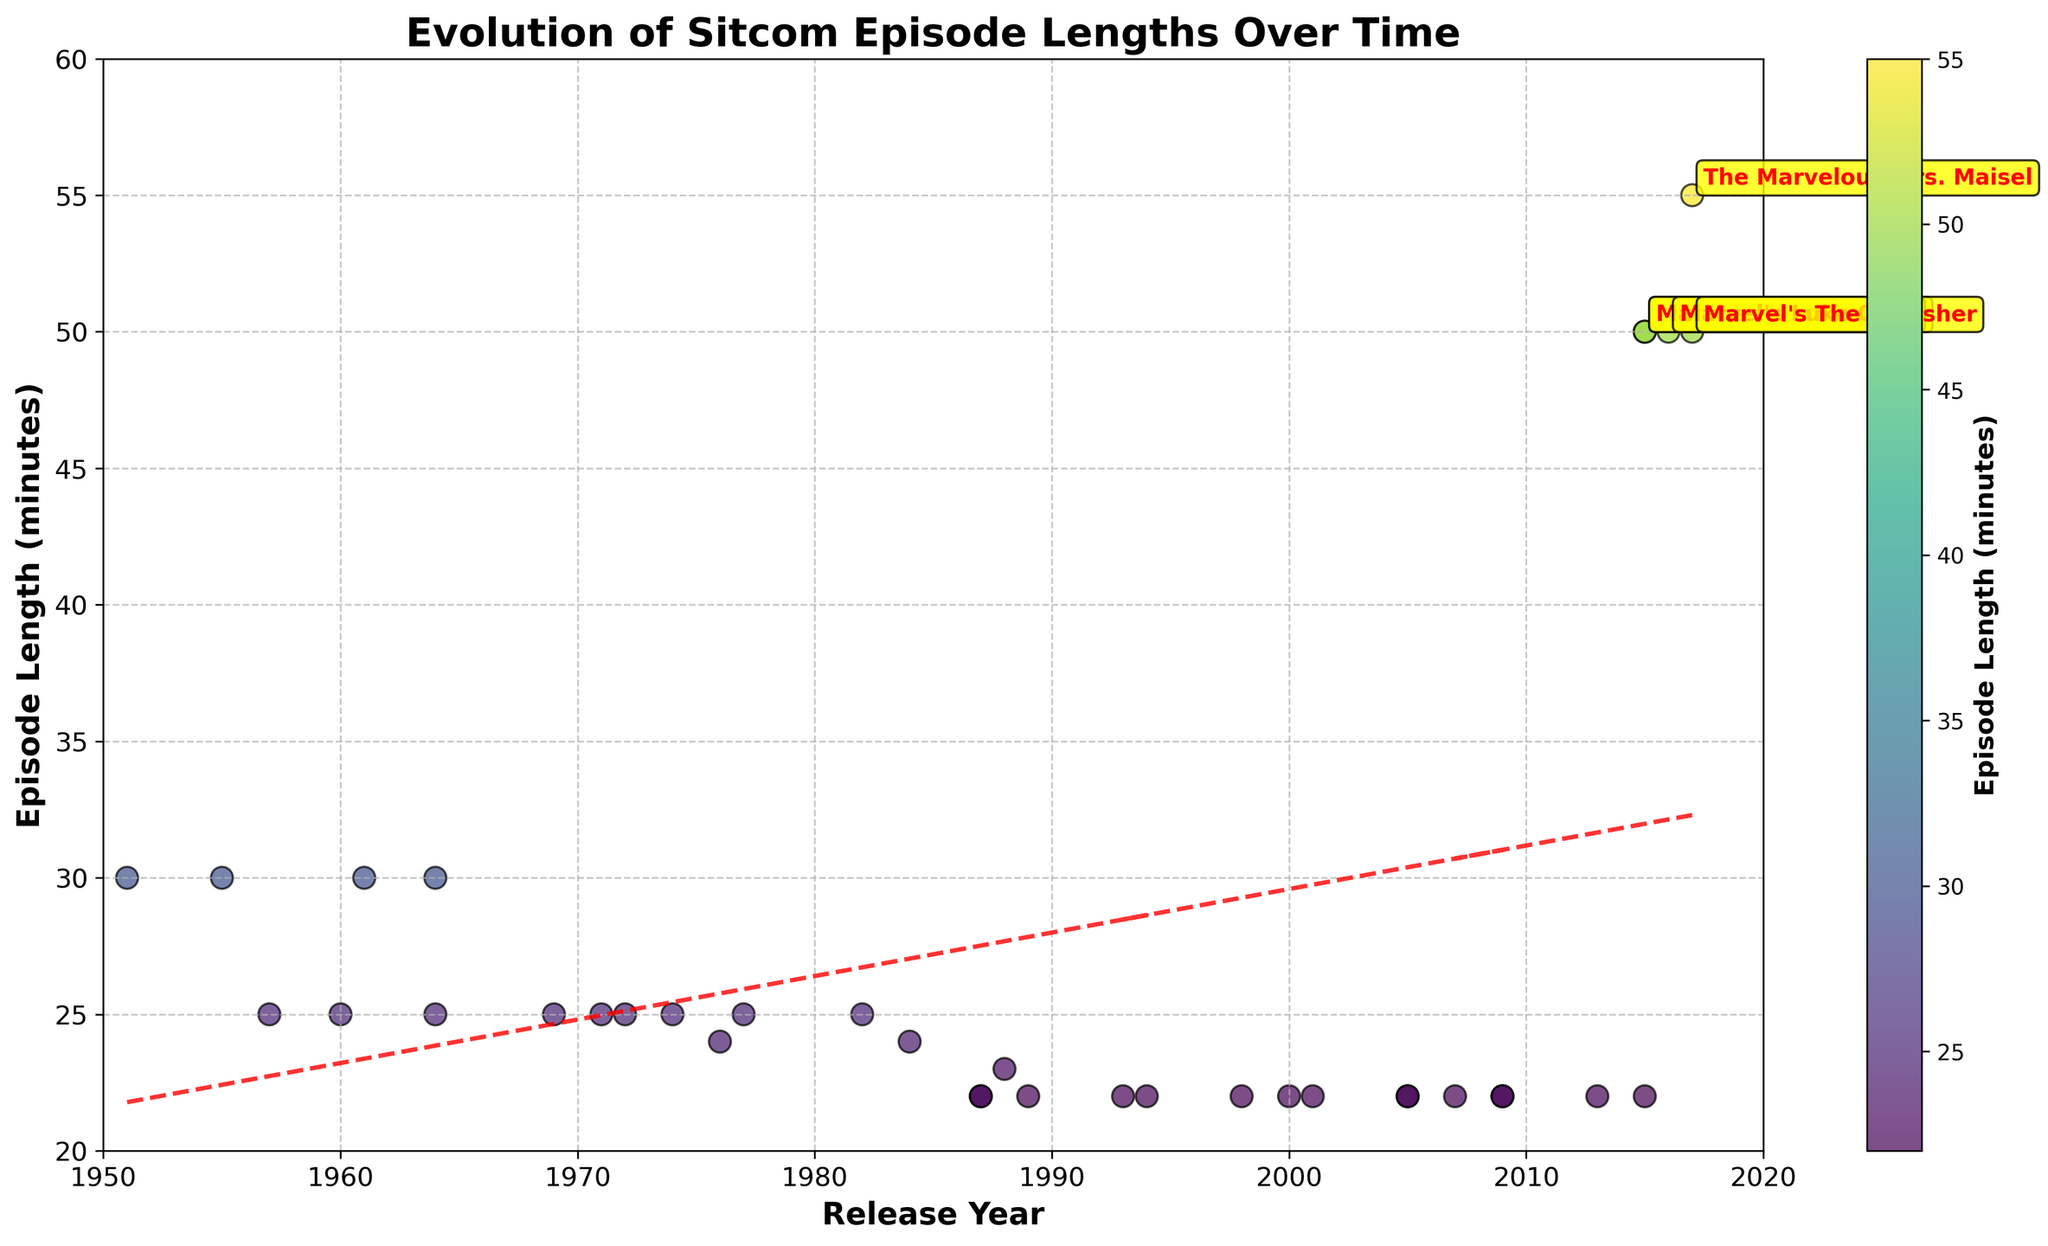What is the title of the plot? The title is usually located at the top of the plot. This plot has "Evolution of Sitcom Episode Lengths Over Time" as its title.
Answer: Evolution of Sitcom Episode Lengths Over Time What are the axes labels of the plot? Axes labels describe what each axis represents. In this plot, the x-axis is labeled "Release Year," and the y-axis is labeled "Episode Length (minutes)."
Answer: Release Year, Episode Length (minutes) What is the average length of sitcom episodes released in the 1960s? Identify the data points from the 1960s and calculate their average. Shows from the 1960s and their lengths are "The Andy Griffith Show" (25 mins), "The Dick Van Dyke Show" (30 mins), "Bewitched" (30 mins), "Gilligan's Island" (25 mins), and "The Brady Bunch" (25 mins). The average is (25 + 30 + 30 + 25 + 25) / 5 = 27
Answer: 27 How many Marvel shows are annotated on the plot? Look for red text with yellow bounding boxes which denote Marvel shows. The shows are "Marvel's Daredevil," "Marvel's Jessica Jones," "Marvel's Luke Cage," and "Marvel's The Punisher," making a total of four.
Answer: 4 Which show has the longest episode length in the dataset? The longest episode length is found by looking for the highest point on the y-axis. "The Marvelous Mrs. Maisel" at 55 minutes is the longest.
Answer: The Marvelous Mrs. Maisel Did episode lengths generally increase or decrease over time, according to the trend line? Observe the direction of the trend line from left to right. The trend line slopes downward, indicating that episode lengths generally decreased over time.
Answer: Decrease Compare episode lengths between "I Love Lucy" and "The Office." Which one is longer? Find the data points for these two shows: "I Love Lucy" has an episode length of 30 minutes, while "The Office" has 22 minutes. Thus, "I Love Lucy" is longer.
Answer: I Love Lucy How many shows from the dataset have an episode length of exactly 22 minutes? Identify the shows on the scatter plot at the 22-minute level. They are: "Married... with Children," "Full House," "Seinfeld," "Friends," "Frasier," "That '70s Show," "Malcolm in the Middle," "Scrubs," "The Office," "How I Met Your Mother," "Parks and Recreation," "Modern Family," "The Big Bang Theory," "Brooklyn Nine-Nine," "Schitt's Creek." There are 15 shows.
Answer: 15 Which decade had the most sitcoms produced, according to the plot? Look for the decade with the highest concentration of data points. The 2000s show the highest density with shows like "Malcolm in the Middle," "Scrubs," "The Office," "How I Met Your Mother," "Parks and Recreation," "Modern Family," "The Big Bang Theory," "Brooklyn Nine-Nine."
Answer: 2000s 